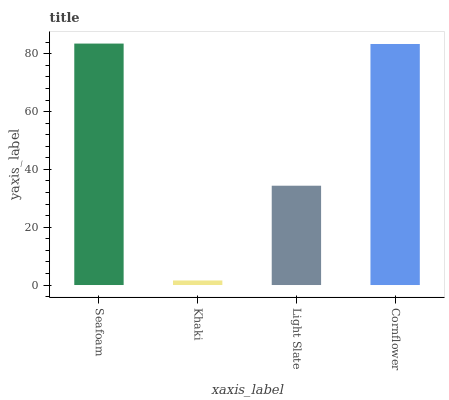Is Khaki the minimum?
Answer yes or no. Yes. Is Seafoam the maximum?
Answer yes or no. Yes. Is Light Slate the minimum?
Answer yes or no. No. Is Light Slate the maximum?
Answer yes or no. No. Is Light Slate greater than Khaki?
Answer yes or no. Yes. Is Khaki less than Light Slate?
Answer yes or no. Yes. Is Khaki greater than Light Slate?
Answer yes or no. No. Is Light Slate less than Khaki?
Answer yes or no. No. Is Cornflower the high median?
Answer yes or no. Yes. Is Light Slate the low median?
Answer yes or no. Yes. Is Light Slate the high median?
Answer yes or no. No. Is Cornflower the low median?
Answer yes or no. No. 